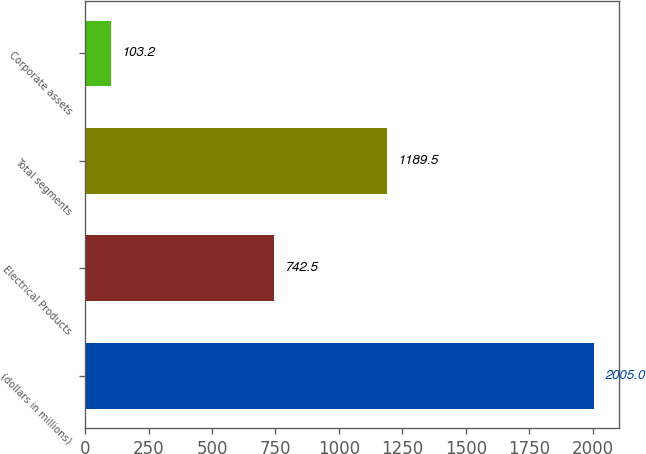Convert chart. <chart><loc_0><loc_0><loc_500><loc_500><bar_chart><fcel>(dollars in millions)<fcel>Electrical Products<fcel>Total segments<fcel>Corporate assets<nl><fcel>2005<fcel>742.5<fcel>1189.5<fcel>103.2<nl></chart> 